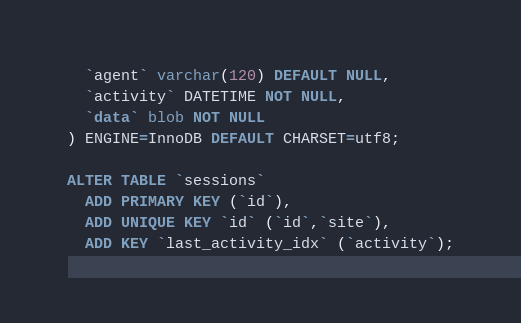<code> <loc_0><loc_0><loc_500><loc_500><_SQL_>  `agent` varchar(120) DEFAULT NULL,
  `activity` DATETIME NOT NULL,
  `data` blob NOT NULL
) ENGINE=InnoDB DEFAULT CHARSET=utf8;

ALTER TABLE `sessions`
  ADD PRIMARY KEY (`id`),
  ADD UNIQUE KEY `id` (`id`,`site`),
  ADD KEY `last_activity_idx` (`activity`);</code> 